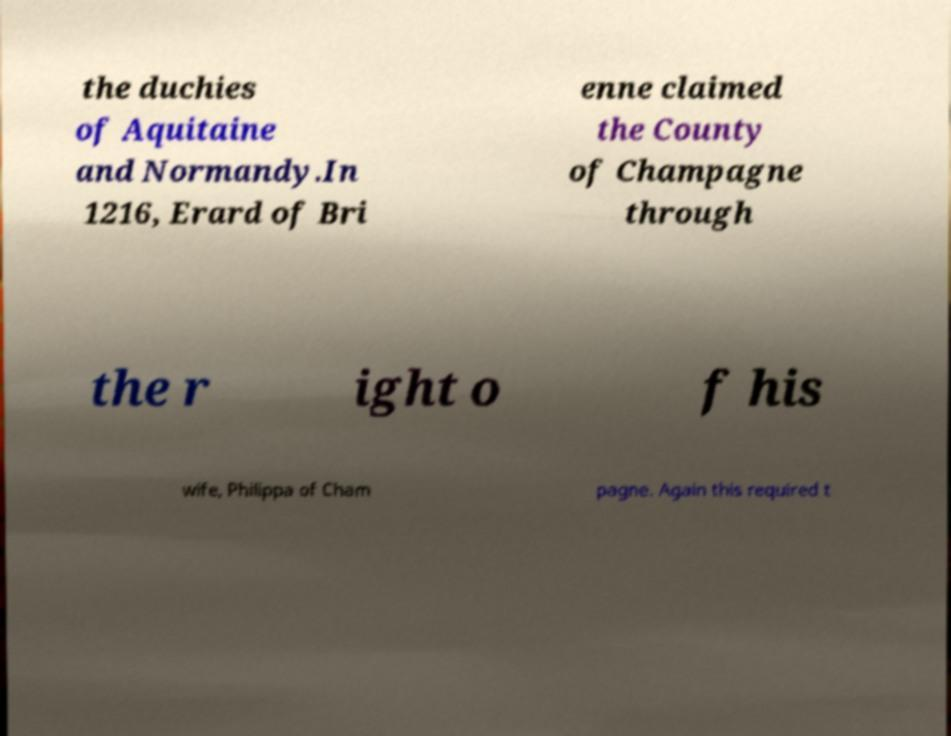Could you assist in decoding the text presented in this image and type it out clearly? the duchies of Aquitaine and Normandy.In 1216, Erard of Bri enne claimed the County of Champagne through the r ight o f his wife, Philippa of Cham pagne. Again this required t 